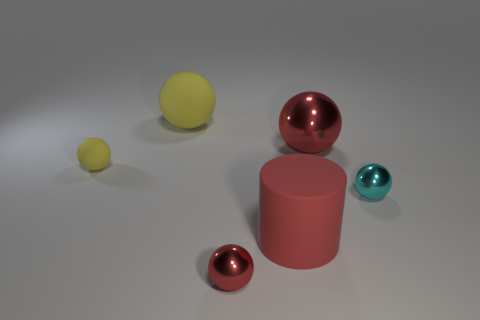Are there an equal number of cylinders on the left side of the small yellow matte object and small brown metallic cubes?
Give a very brief answer. Yes. What number of big spheres are the same color as the matte cylinder?
Give a very brief answer. 1. There is a big matte thing that is the same shape as the large red metallic object; what color is it?
Ensure brevity in your answer.  Yellow. Do the red rubber thing and the cyan thing have the same size?
Provide a short and direct response. No. Are there an equal number of tiny things behind the big yellow rubber sphere and big objects that are on the right side of the tiny red metallic ball?
Your answer should be very brief. No. Is there a tiny gray matte cylinder?
Offer a terse response. No. There is another red shiny thing that is the same shape as the large metallic object; what size is it?
Your answer should be very brief. Small. How big is the red ball on the right side of the big red matte thing?
Your answer should be very brief. Large. Is the number of small metallic spheres left of the large cylinder greater than the number of tiny blue blocks?
Your response must be concise. Yes. What is the shape of the red rubber object?
Give a very brief answer. Cylinder. 